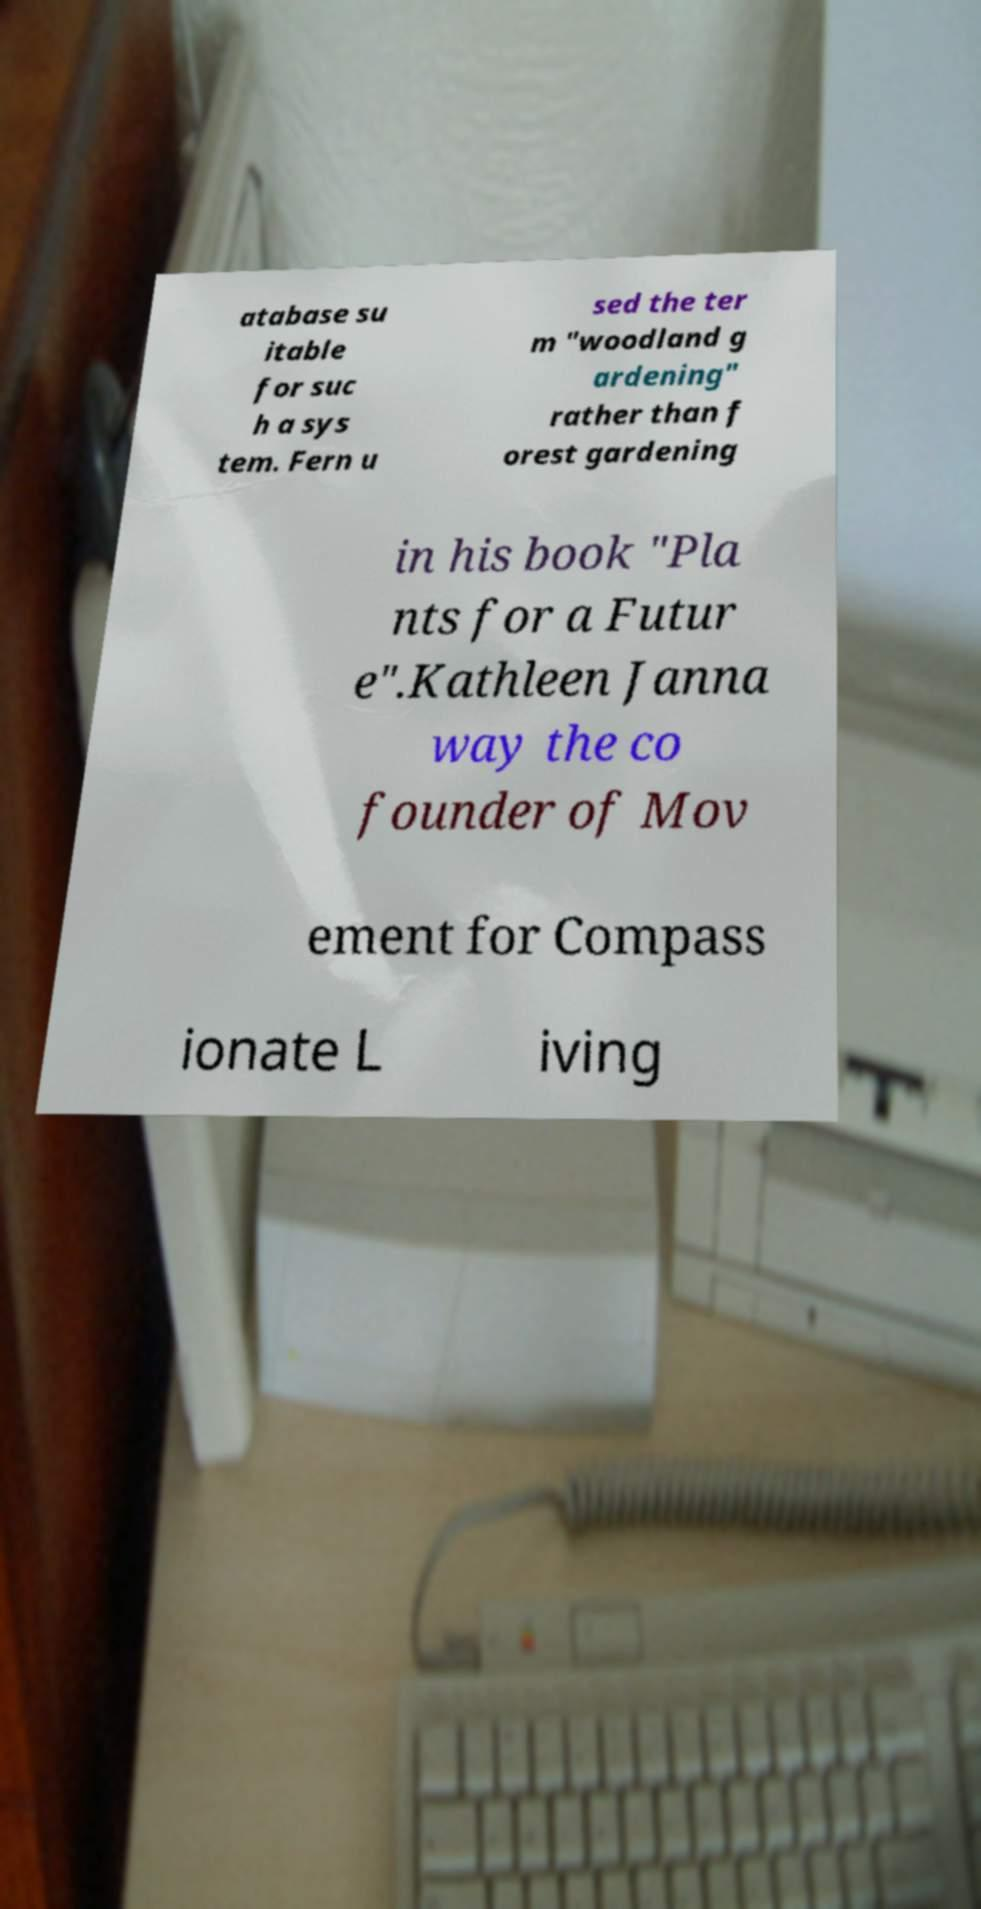Can you accurately transcribe the text from the provided image for me? atabase su itable for suc h a sys tem. Fern u sed the ter m "woodland g ardening" rather than f orest gardening in his book "Pla nts for a Futur e".Kathleen Janna way the co founder of Mov ement for Compass ionate L iving 